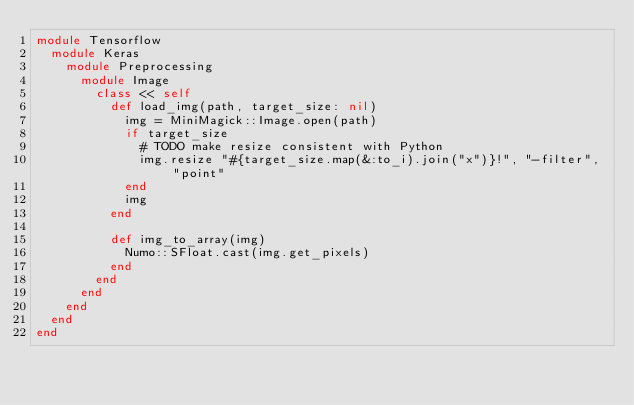Convert code to text. <code><loc_0><loc_0><loc_500><loc_500><_Ruby_>module Tensorflow
  module Keras
    module Preprocessing
      module Image
        class << self
          def load_img(path, target_size: nil)
            img = MiniMagick::Image.open(path)
            if target_size
              # TODO make resize consistent with Python
              img.resize "#{target_size.map(&:to_i).join("x")}!", "-filter", "point"
            end
            img
          end

          def img_to_array(img)
            Numo::SFloat.cast(img.get_pixels)
          end
        end
      end
    end
  end
end
</code> 